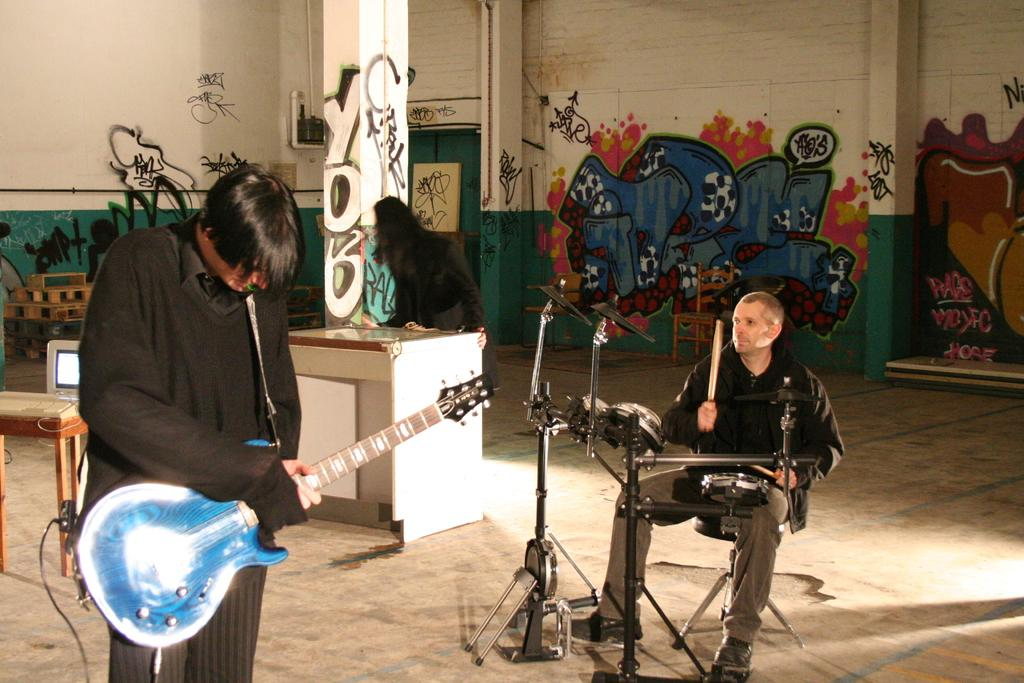What are the persons in the image doing? The persons in the image are holding musical instruments. Can you describe the woman's position in the image? The woman is standing on the floor in the image. What type of furniture is present in the image? There is a desktop on a side table in the image. What can be seen attached to the walls in the image? Pipelines are attached to the walls in the image. What is present on the walls in the image? The walls have graffiti in the image. How many trucks are parked outside the building in the image? There is no information about trucks or a building in the image; it only shows persons holding musical instruments, a woman standing on the floor, a desktop on a side table, pipelines attached to the walls, and graffiti on the walls. What type of hole can be seen in the image? There is no hole present in the image. 